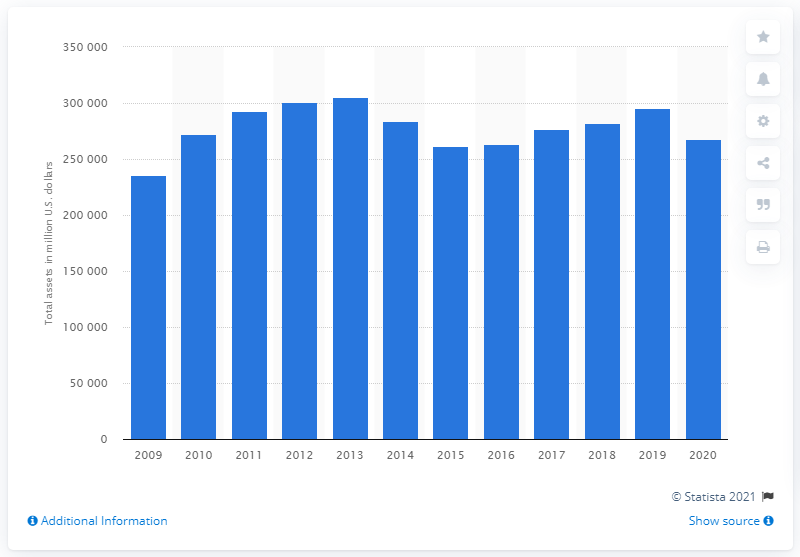Indicate a few pertinent items in this graphic. In 2020, BP had a total assets value of 267,654. In 2013, BP reported the greatest total assets. 